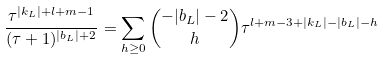<formula> <loc_0><loc_0><loc_500><loc_500>\frac { \tau ^ { | k _ { L } | + l + m - 1 } } { ( \tau + 1 ) ^ { | b _ { L } | + 2 } } = \sum _ { h \geq 0 } \binom { - | b _ { L } | - 2 } { h } \tau ^ { l + m - 3 + | k _ { L } | - | b _ { L } | - h }</formula> 